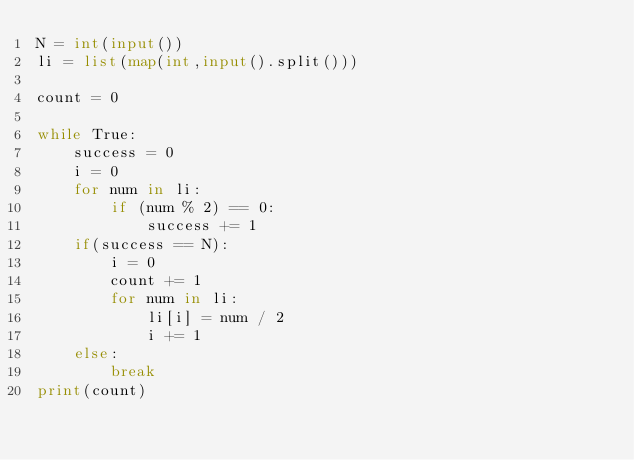Convert code to text. <code><loc_0><loc_0><loc_500><loc_500><_Python_>N = int(input())
li = list(map(int,input().split()))

count = 0

while True:
    success = 0
    i = 0
    for num in li:
        if (num % 2) == 0:
            success += 1
    if(success == N):
        i = 0
        count += 1
        for num in li:
            li[i] = num / 2
            i += 1
    else:
        break
print(count)</code> 